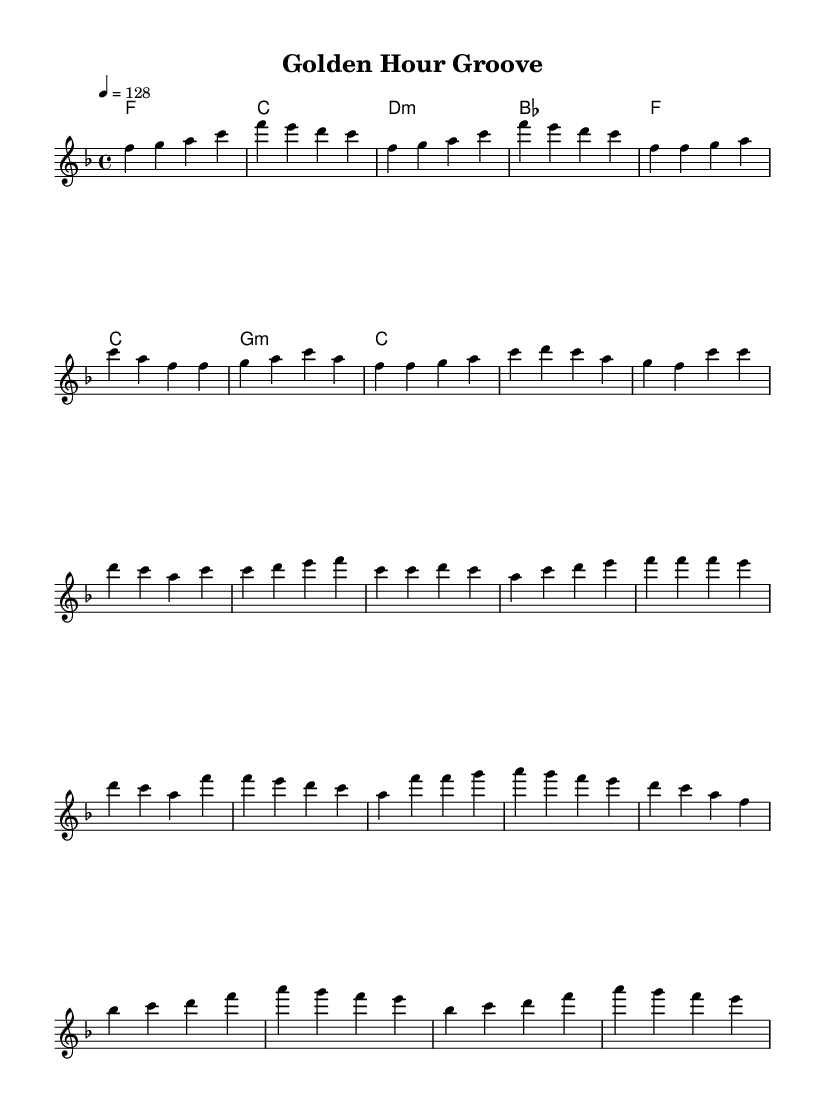What is the key signature of this music? The key signature has one flat, which indicates that it is in F major.
Answer: F major What is the time signature of this music? The time signature is indicated by the fraction 4/4 at the beginning, which means there are four beats in a measure and the quarter note gets one beat.
Answer: 4/4 What is the tempo marking in this music? The tempo marking '4 = 128' indicates that there should be 128 beats per minute, which sets a moderate fast pace for the piece.
Answer: 128 What is the first note of the melody? The first note is indicated in the melody section and is labeled as an F in the first measure.
Answer: F How many measures does the bridge section consist of? By counting the measures in the bridge section of the provided melody, it includes four measures total.
Answer: 4 What is the last chord in the harmonies section? The chord is indicated right after the melody lines; the last chord listed is E minor.
Answer: E minor Which part of the music is labeled as the "Chorus"? The chorus section is identified in the sheet music with the respective content directly contrasting the verse, specifically noted as the first section after the pre-chorus.
Answer: Chorus 